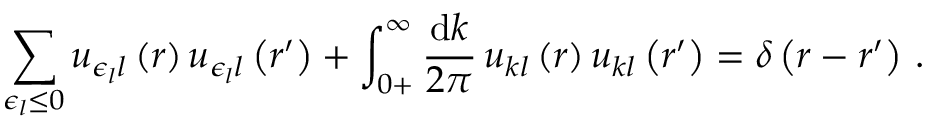Convert formula to latex. <formula><loc_0><loc_0><loc_500><loc_500>\sum _ { \epsilon _ { l } \leq 0 } u _ { \epsilon _ { l } l } \left ( r \right ) u _ { \epsilon _ { l } l } \left ( r ^ { \prime } \right ) + \int _ { 0 + } ^ { \infty } \frac { d k } { 2 \pi } \, u _ { k l } \left ( r \right ) u _ { k l } \left ( r ^ { \prime } \right ) = \delta \left ( r - r ^ { \prime } \right ) \, .</formula> 